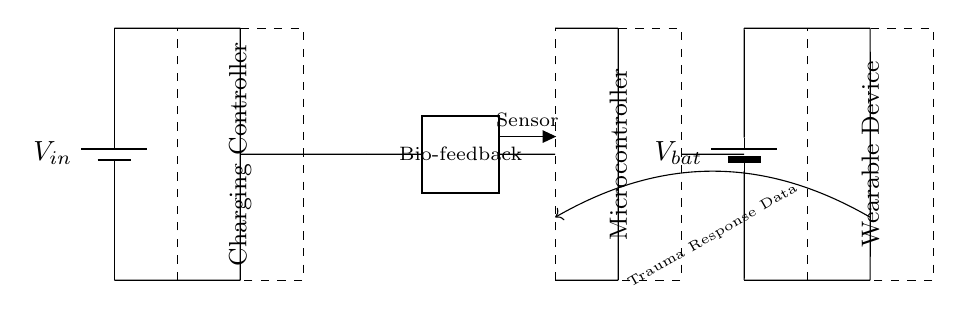What is the input voltage of the circuit? The input voltage is labeled as V_in on the battery symbol located at the left of the diagram. It specifies the voltage supplied to the circuit for charging.
Answer: V_in What does the dashed rectangle represent? The dashed rectangle encloses the charging controller, which is indicated by the label inside the rectangle. This component manages the charging process.
Answer: Charging Controller How many main components are in this circuit? The circuit contains four main components: a power source (battery), a charging controller, a microcontroller, and a wearable device. I counted each component represented in the diagram to determine this total.
Answer: Four What type of feedback does the system utilize? The system utilizes trauma response data, indicated by the labeled arrow pointing from the wearable device to the microcontroller, suggesting a feedback loop that includes data related to trauma.
Answer: Trauma Response Data Which component stores energy for the wearable device? The energy storage for the wearable device is provided by the second battery labeled V_bat located towards the right side of the diagram. This is the primary source of stored energy for the wearable.
Answer: V_bat Why is the bio-feedback sensor essential in this circuit? The bio-feedback sensor acts as a crucial interface, capturing physiological data during therapy sessions, which influences the charging system's decisions. The two-port symbol identifies it as a measurement device.
Answer: Capturing physiological data How is the microcontroller powered in this circuit? The microcontroller is powered via direct connections from both the battery and the charging controller, ensuring it receives the necessary voltage for operation, as indicated by the lines connecting these components.
Answer: Through connections from the battery and controller 